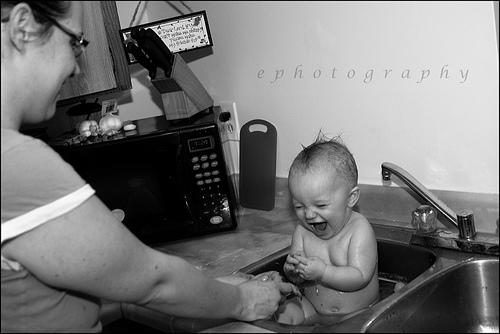Who is most likely bathing the baby?

Choices:
A) sister
B) nanny
C) grandmother
D) mom mom 